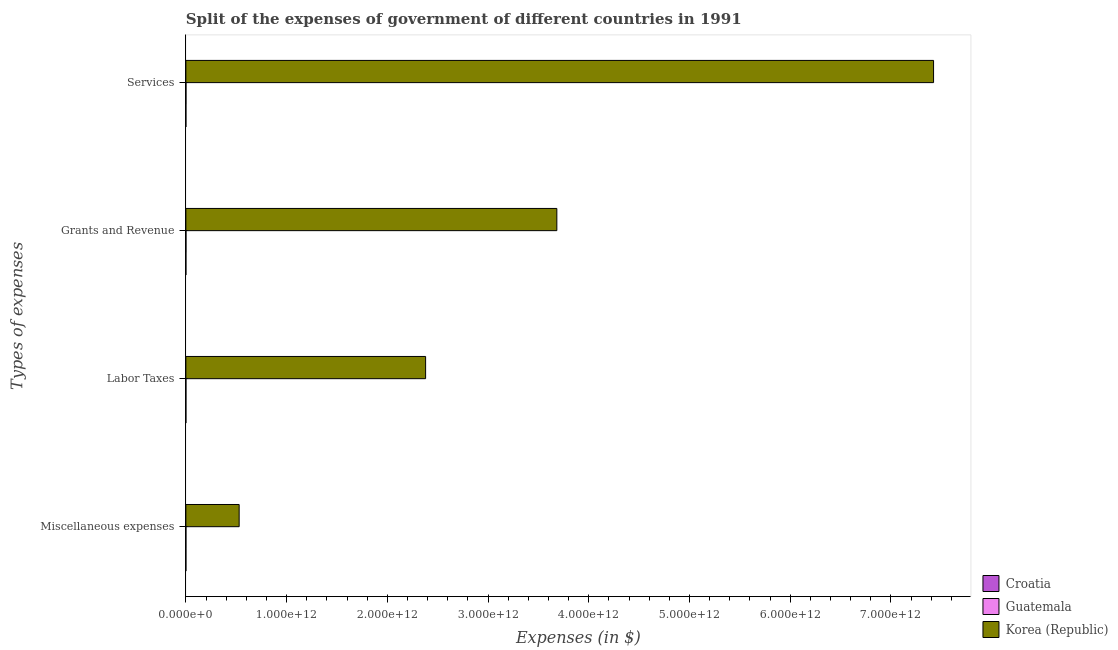How many different coloured bars are there?
Give a very brief answer. 3. Are the number of bars per tick equal to the number of legend labels?
Make the answer very short. Yes. How many bars are there on the 4th tick from the bottom?
Ensure brevity in your answer.  3. What is the label of the 1st group of bars from the top?
Make the answer very short. Services. What is the amount spent on labor taxes in Croatia?
Keep it short and to the point. 4.70e+05. Across all countries, what is the maximum amount spent on grants and revenue?
Offer a terse response. 3.68e+12. Across all countries, what is the minimum amount spent on labor taxes?
Give a very brief answer. 4.70e+05. In which country was the amount spent on labor taxes maximum?
Give a very brief answer. Korea (Republic). In which country was the amount spent on labor taxes minimum?
Provide a succinct answer. Croatia. What is the total amount spent on grants and revenue in the graph?
Make the answer very short. 3.68e+12. What is the difference between the amount spent on grants and revenue in Guatemala and that in Korea (Republic)?
Your answer should be very brief. -3.68e+12. What is the difference between the amount spent on grants and revenue in Guatemala and the amount spent on miscellaneous expenses in Korea (Republic)?
Your response must be concise. -5.28e+11. What is the average amount spent on labor taxes per country?
Your answer should be very brief. 7.93e+11. What is the difference between the amount spent on grants and revenue and amount spent on labor taxes in Guatemala?
Offer a very short reply. 4.08e+08. What is the ratio of the amount spent on miscellaneous expenses in Croatia to that in Guatemala?
Offer a terse response. 0. Is the difference between the amount spent on services in Guatemala and Croatia greater than the difference between the amount spent on grants and revenue in Guatemala and Croatia?
Offer a very short reply. No. What is the difference between the highest and the second highest amount spent on labor taxes?
Provide a short and direct response. 2.38e+12. What is the difference between the highest and the lowest amount spent on services?
Provide a succinct answer. 7.42e+12. In how many countries, is the amount spent on miscellaneous expenses greater than the average amount spent on miscellaneous expenses taken over all countries?
Give a very brief answer. 1. What does the 1st bar from the top in Grants and Revenue represents?
Your answer should be compact. Korea (Republic). Is it the case that in every country, the sum of the amount spent on miscellaneous expenses and amount spent on labor taxes is greater than the amount spent on grants and revenue?
Make the answer very short. No. Are all the bars in the graph horizontal?
Your response must be concise. Yes. How many countries are there in the graph?
Offer a terse response. 3. What is the difference between two consecutive major ticks on the X-axis?
Give a very brief answer. 1.00e+12. Are the values on the major ticks of X-axis written in scientific E-notation?
Your answer should be very brief. Yes. Does the graph contain any zero values?
Make the answer very short. No. Where does the legend appear in the graph?
Provide a short and direct response. Bottom right. How are the legend labels stacked?
Your response must be concise. Vertical. What is the title of the graph?
Offer a very short reply. Split of the expenses of government of different countries in 1991. Does "Philippines" appear as one of the legend labels in the graph?
Offer a terse response. No. What is the label or title of the X-axis?
Offer a terse response. Expenses (in $). What is the label or title of the Y-axis?
Keep it short and to the point. Types of expenses. What is the Expenses (in $) of Guatemala in Miscellaneous expenses?
Your response must be concise. 1.04e+08. What is the Expenses (in $) in Korea (Republic) in Miscellaneous expenses?
Your answer should be compact. 5.29e+11. What is the Expenses (in $) in Guatemala in Labor Taxes?
Make the answer very short. 3.02e+08. What is the Expenses (in $) in Korea (Republic) in Labor Taxes?
Your answer should be compact. 2.38e+12. What is the Expenses (in $) of Croatia in Grants and Revenue?
Make the answer very short. 4.88e+06. What is the Expenses (in $) in Guatemala in Grants and Revenue?
Keep it short and to the point. 7.09e+08. What is the Expenses (in $) of Korea (Republic) in Grants and Revenue?
Provide a short and direct response. 3.68e+12. What is the Expenses (in $) of Croatia in Services?
Offer a very short reply. 5.30e+07. What is the Expenses (in $) of Guatemala in Services?
Provide a succinct answer. 7.25e+08. What is the Expenses (in $) in Korea (Republic) in Services?
Offer a terse response. 7.42e+12. Across all Types of expenses, what is the maximum Expenses (in $) in Croatia?
Give a very brief answer. 5.30e+07. Across all Types of expenses, what is the maximum Expenses (in $) in Guatemala?
Give a very brief answer. 7.25e+08. Across all Types of expenses, what is the maximum Expenses (in $) in Korea (Republic)?
Provide a succinct answer. 7.42e+12. Across all Types of expenses, what is the minimum Expenses (in $) in Croatia?
Provide a short and direct response. 3.00e+05. Across all Types of expenses, what is the minimum Expenses (in $) of Guatemala?
Keep it short and to the point. 1.04e+08. Across all Types of expenses, what is the minimum Expenses (in $) of Korea (Republic)?
Your answer should be compact. 5.29e+11. What is the total Expenses (in $) of Croatia in the graph?
Provide a succinct answer. 5.86e+07. What is the total Expenses (in $) in Guatemala in the graph?
Your response must be concise. 1.84e+09. What is the total Expenses (in $) of Korea (Republic) in the graph?
Ensure brevity in your answer.  1.40e+13. What is the difference between the Expenses (in $) of Guatemala in Miscellaneous expenses and that in Labor Taxes?
Make the answer very short. -1.98e+08. What is the difference between the Expenses (in $) in Korea (Republic) in Miscellaneous expenses and that in Labor Taxes?
Your response must be concise. -1.85e+12. What is the difference between the Expenses (in $) of Croatia in Miscellaneous expenses and that in Grants and Revenue?
Offer a terse response. -4.58e+06. What is the difference between the Expenses (in $) of Guatemala in Miscellaneous expenses and that in Grants and Revenue?
Provide a short and direct response. -6.06e+08. What is the difference between the Expenses (in $) of Korea (Republic) in Miscellaneous expenses and that in Grants and Revenue?
Provide a short and direct response. -3.15e+12. What is the difference between the Expenses (in $) of Croatia in Miscellaneous expenses and that in Services?
Give a very brief answer. -5.27e+07. What is the difference between the Expenses (in $) in Guatemala in Miscellaneous expenses and that in Services?
Your response must be concise. -6.22e+08. What is the difference between the Expenses (in $) in Korea (Republic) in Miscellaneous expenses and that in Services?
Give a very brief answer. -6.89e+12. What is the difference between the Expenses (in $) in Croatia in Labor Taxes and that in Grants and Revenue?
Keep it short and to the point. -4.41e+06. What is the difference between the Expenses (in $) of Guatemala in Labor Taxes and that in Grants and Revenue?
Provide a succinct answer. -4.08e+08. What is the difference between the Expenses (in $) in Korea (Republic) in Labor Taxes and that in Grants and Revenue?
Your answer should be very brief. -1.30e+12. What is the difference between the Expenses (in $) in Croatia in Labor Taxes and that in Services?
Give a very brief answer. -5.25e+07. What is the difference between the Expenses (in $) of Guatemala in Labor Taxes and that in Services?
Give a very brief answer. -4.23e+08. What is the difference between the Expenses (in $) of Korea (Republic) in Labor Taxes and that in Services?
Your answer should be very brief. -5.04e+12. What is the difference between the Expenses (in $) of Croatia in Grants and Revenue and that in Services?
Offer a terse response. -4.81e+07. What is the difference between the Expenses (in $) in Guatemala in Grants and Revenue and that in Services?
Your answer should be compact. -1.58e+07. What is the difference between the Expenses (in $) in Korea (Republic) in Grants and Revenue and that in Services?
Your answer should be very brief. -3.74e+12. What is the difference between the Expenses (in $) of Croatia in Miscellaneous expenses and the Expenses (in $) of Guatemala in Labor Taxes?
Provide a succinct answer. -3.02e+08. What is the difference between the Expenses (in $) in Croatia in Miscellaneous expenses and the Expenses (in $) in Korea (Republic) in Labor Taxes?
Give a very brief answer. -2.38e+12. What is the difference between the Expenses (in $) in Guatemala in Miscellaneous expenses and the Expenses (in $) in Korea (Republic) in Labor Taxes?
Your response must be concise. -2.38e+12. What is the difference between the Expenses (in $) in Croatia in Miscellaneous expenses and the Expenses (in $) in Guatemala in Grants and Revenue?
Give a very brief answer. -7.09e+08. What is the difference between the Expenses (in $) of Croatia in Miscellaneous expenses and the Expenses (in $) of Korea (Republic) in Grants and Revenue?
Ensure brevity in your answer.  -3.68e+12. What is the difference between the Expenses (in $) in Guatemala in Miscellaneous expenses and the Expenses (in $) in Korea (Republic) in Grants and Revenue?
Provide a short and direct response. -3.68e+12. What is the difference between the Expenses (in $) of Croatia in Miscellaneous expenses and the Expenses (in $) of Guatemala in Services?
Provide a succinct answer. -7.25e+08. What is the difference between the Expenses (in $) in Croatia in Miscellaneous expenses and the Expenses (in $) in Korea (Republic) in Services?
Make the answer very short. -7.42e+12. What is the difference between the Expenses (in $) of Guatemala in Miscellaneous expenses and the Expenses (in $) of Korea (Republic) in Services?
Offer a very short reply. -7.42e+12. What is the difference between the Expenses (in $) of Croatia in Labor Taxes and the Expenses (in $) of Guatemala in Grants and Revenue?
Make the answer very short. -7.09e+08. What is the difference between the Expenses (in $) of Croatia in Labor Taxes and the Expenses (in $) of Korea (Republic) in Grants and Revenue?
Make the answer very short. -3.68e+12. What is the difference between the Expenses (in $) in Guatemala in Labor Taxes and the Expenses (in $) in Korea (Republic) in Grants and Revenue?
Ensure brevity in your answer.  -3.68e+12. What is the difference between the Expenses (in $) of Croatia in Labor Taxes and the Expenses (in $) of Guatemala in Services?
Make the answer very short. -7.25e+08. What is the difference between the Expenses (in $) in Croatia in Labor Taxes and the Expenses (in $) in Korea (Republic) in Services?
Offer a very short reply. -7.42e+12. What is the difference between the Expenses (in $) in Guatemala in Labor Taxes and the Expenses (in $) in Korea (Republic) in Services?
Make the answer very short. -7.42e+12. What is the difference between the Expenses (in $) of Croatia in Grants and Revenue and the Expenses (in $) of Guatemala in Services?
Make the answer very short. -7.20e+08. What is the difference between the Expenses (in $) in Croatia in Grants and Revenue and the Expenses (in $) in Korea (Republic) in Services?
Provide a short and direct response. -7.42e+12. What is the difference between the Expenses (in $) of Guatemala in Grants and Revenue and the Expenses (in $) of Korea (Republic) in Services?
Offer a very short reply. -7.42e+12. What is the average Expenses (in $) of Croatia per Types of expenses?
Provide a succinct answer. 1.47e+07. What is the average Expenses (in $) of Guatemala per Types of expenses?
Offer a very short reply. 4.60e+08. What is the average Expenses (in $) of Korea (Republic) per Types of expenses?
Your answer should be very brief. 3.50e+12. What is the difference between the Expenses (in $) of Croatia and Expenses (in $) of Guatemala in Miscellaneous expenses?
Your answer should be very brief. -1.03e+08. What is the difference between the Expenses (in $) in Croatia and Expenses (in $) in Korea (Republic) in Miscellaneous expenses?
Make the answer very short. -5.29e+11. What is the difference between the Expenses (in $) of Guatemala and Expenses (in $) of Korea (Republic) in Miscellaneous expenses?
Provide a short and direct response. -5.29e+11. What is the difference between the Expenses (in $) of Croatia and Expenses (in $) of Guatemala in Labor Taxes?
Your response must be concise. -3.01e+08. What is the difference between the Expenses (in $) in Croatia and Expenses (in $) in Korea (Republic) in Labor Taxes?
Offer a terse response. -2.38e+12. What is the difference between the Expenses (in $) in Guatemala and Expenses (in $) in Korea (Republic) in Labor Taxes?
Provide a short and direct response. -2.38e+12. What is the difference between the Expenses (in $) of Croatia and Expenses (in $) of Guatemala in Grants and Revenue?
Keep it short and to the point. -7.05e+08. What is the difference between the Expenses (in $) in Croatia and Expenses (in $) in Korea (Republic) in Grants and Revenue?
Your response must be concise. -3.68e+12. What is the difference between the Expenses (in $) of Guatemala and Expenses (in $) of Korea (Republic) in Grants and Revenue?
Offer a terse response. -3.68e+12. What is the difference between the Expenses (in $) of Croatia and Expenses (in $) of Guatemala in Services?
Keep it short and to the point. -6.72e+08. What is the difference between the Expenses (in $) in Croatia and Expenses (in $) in Korea (Republic) in Services?
Offer a terse response. -7.42e+12. What is the difference between the Expenses (in $) of Guatemala and Expenses (in $) of Korea (Republic) in Services?
Keep it short and to the point. -7.42e+12. What is the ratio of the Expenses (in $) of Croatia in Miscellaneous expenses to that in Labor Taxes?
Make the answer very short. 0.64. What is the ratio of the Expenses (in $) in Guatemala in Miscellaneous expenses to that in Labor Taxes?
Your response must be concise. 0.34. What is the ratio of the Expenses (in $) of Korea (Republic) in Miscellaneous expenses to that in Labor Taxes?
Provide a succinct answer. 0.22. What is the ratio of the Expenses (in $) in Croatia in Miscellaneous expenses to that in Grants and Revenue?
Keep it short and to the point. 0.06. What is the ratio of the Expenses (in $) in Guatemala in Miscellaneous expenses to that in Grants and Revenue?
Offer a very short reply. 0.15. What is the ratio of the Expenses (in $) of Korea (Republic) in Miscellaneous expenses to that in Grants and Revenue?
Your answer should be very brief. 0.14. What is the ratio of the Expenses (in $) in Croatia in Miscellaneous expenses to that in Services?
Keep it short and to the point. 0.01. What is the ratio of the Expenses (in $) in Guatemala in Miscellaneous expenses to that in Services?
Your answer should be very brief. 0.14. What is the ratio of the Expenses (in $) of Korea (Republic) in Miscellaneous expenses to that in Services?
Your answer should be compact. 0.07. What is the ratio of the Expenses (in $) of Croatia in Labor Taxes to that in Grants and Revenue?
Ensure brevity in your answer.  0.1. What is the ratio of the Expenses (in $) in Guatemala in Labor Taxes to that in Grants and Revenue?
Your answer should be compact. 0.43. What is the ratio of the Expenses (in $) of Korea (Republic) in Labor Taxes to that in Grants and Revenue?
Provide a short and direct response. 0.65. What is the ratio of the Expenses (in $) of Croatia in Labor Taxes to that in Services?
Ensure brevity in your answer.  0.01. What is the ratio of the Expenses (in $) of Guatemala in Labor Taxes to that in Services?
Keep it short and to the point. 0.42. What is the ratio of the Expenses (in $) of Korea (Republic) in Labor Taxes to that in Services?
Your response must be concise. 0.32. What is the ratio of the Expenses (in $) in Croatia in Grants and Revenue to that in Services?
Ensure brevity in your answer.  0.09. What is the ratio of the Expenses (in $) of Guatemala in Grants and Revenue to that in Services?
Provide a succinct answer. 0.98. What is the ratio of the Expenses (in $) in Korea (Republic) in Grants and Revenue to that in Services?
Your answer should be very brief. 0.5. What is the difference between the highest and the second highest Expenses (in $) of Croatia?
Ensure brevity in your answer.  4.81e+07. What is the difference between the highest and the second highest Expenses (in $) in Guatemala?
Your answer should be compact. 1.58e+07. What is the difference between the highest and the second highest Expenses (in $) in Korea (Republic)?
Your answer should be compact. 3.74e+12. What is the difference between the highest and the lowest Expenses (in $) in Croatia?
Your answer should be compact. 5.27e+07. What is the difference between the highest and the lowest Expenses (in $) in Guatemala?
Make the answer very short. 6.22e+08. What is the difference between the highest and the lowest Expenses (in $) in Korea (Republic)?
Your answer should be very brief. 6.89e+12. 